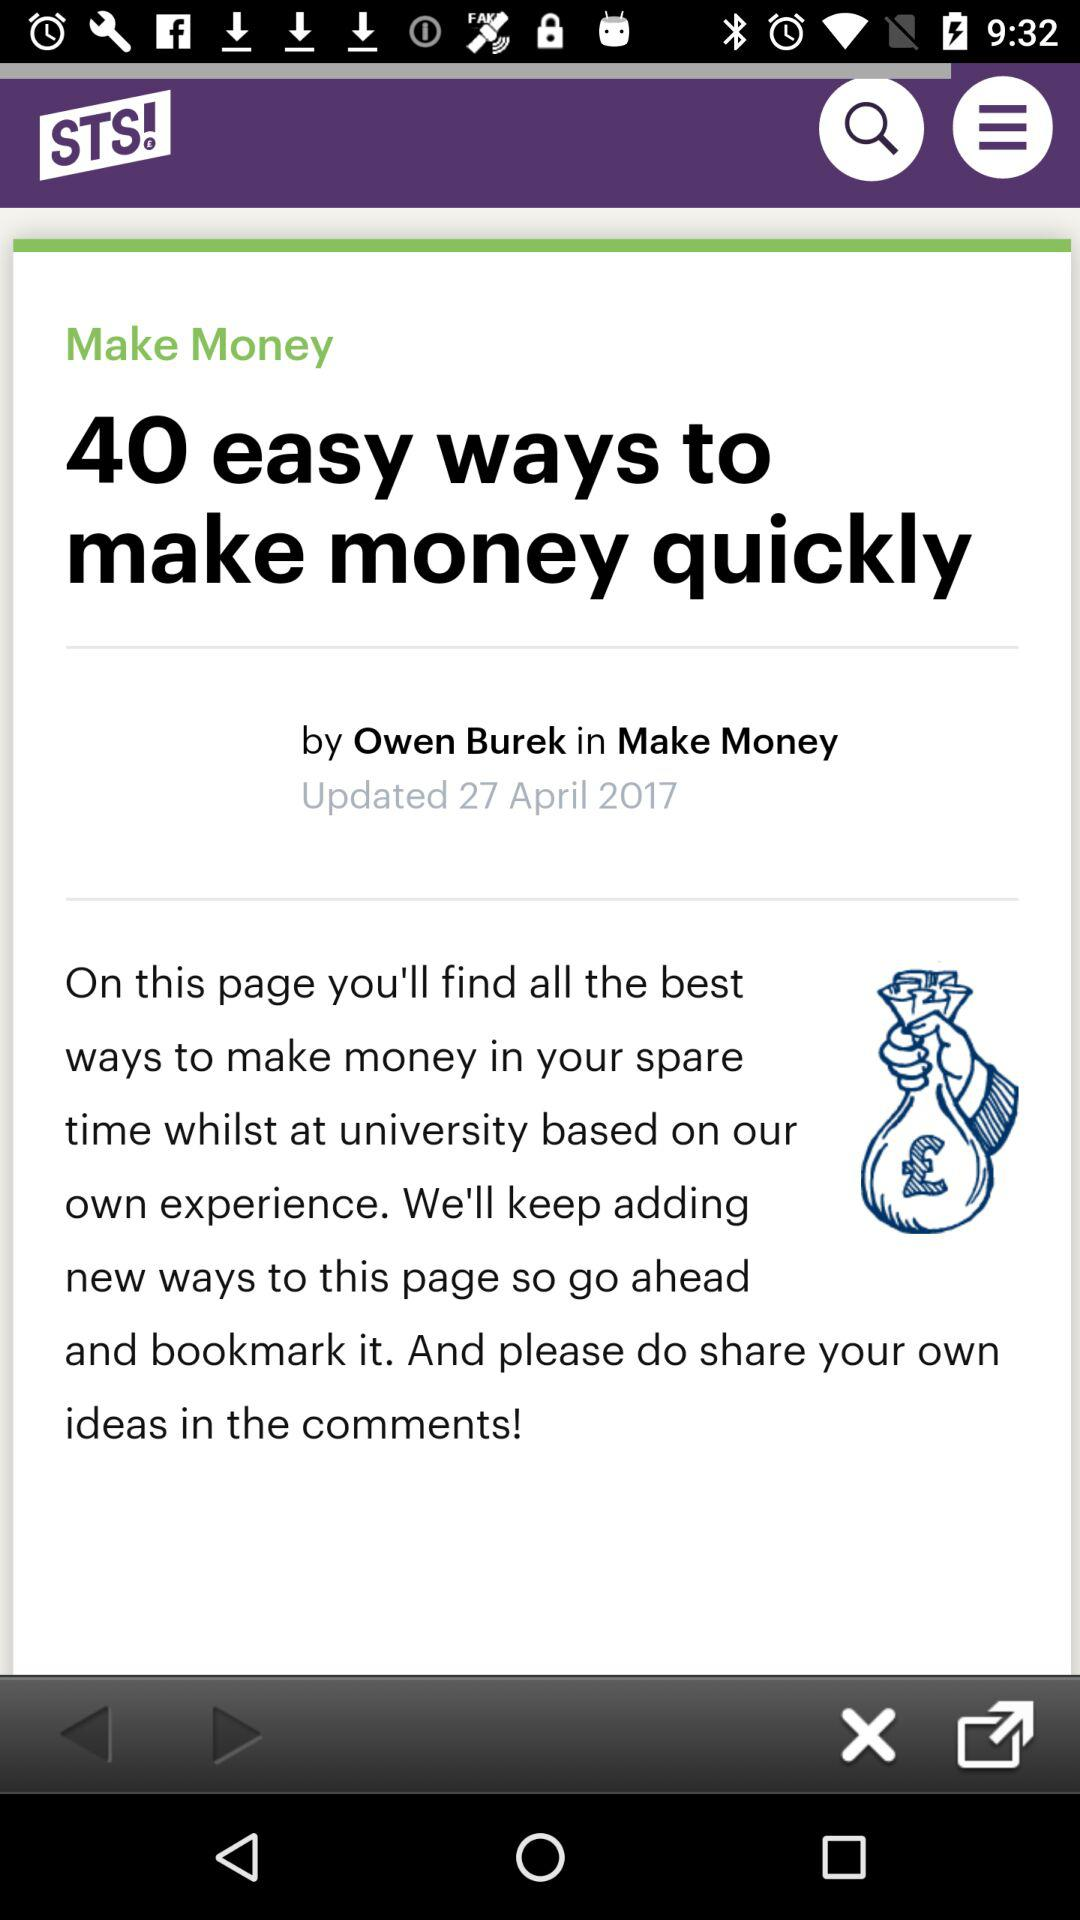Who is the author of the article posted on "Make Money"? The author of the article is Owen Burek. 